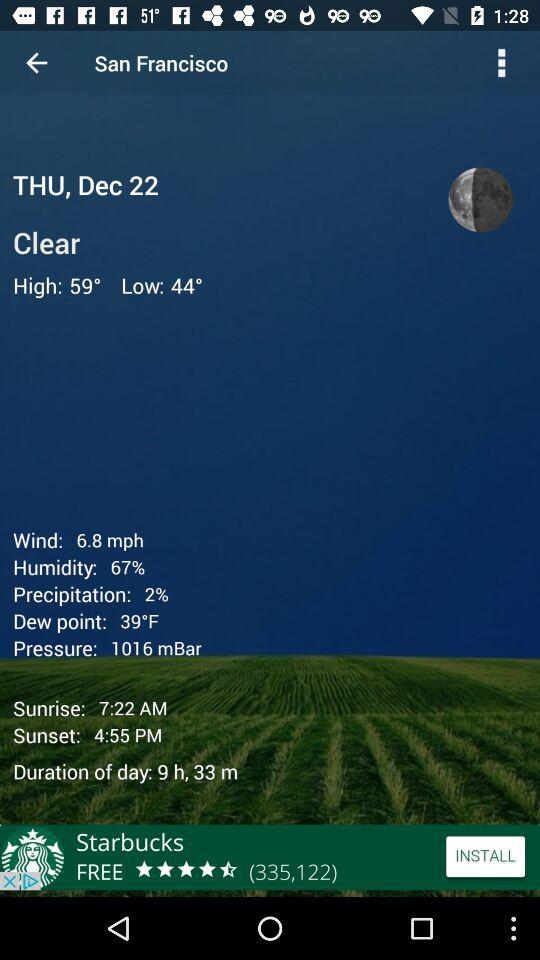What is the day on the given date? The day on the given date is Thursday. 